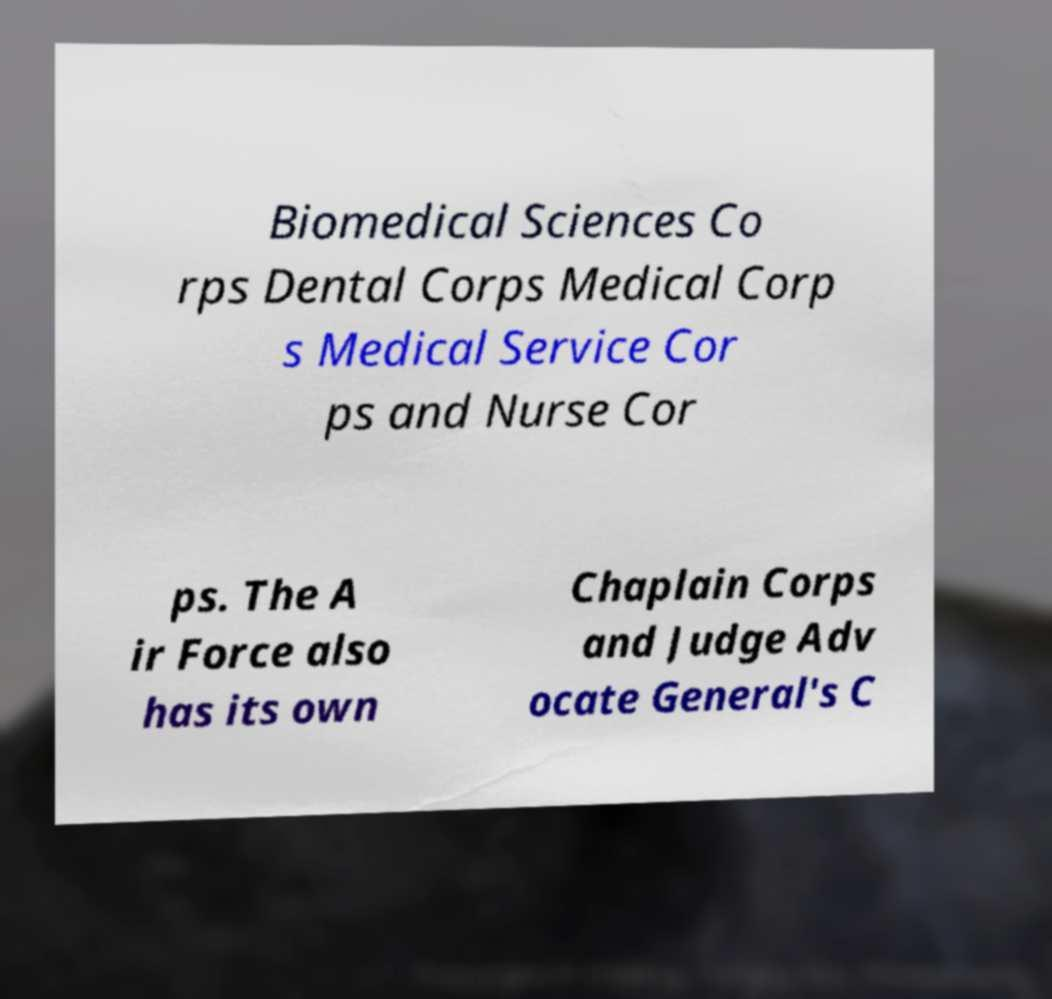Please read and relay the text visible in this image. What does it say? Biomedical Sciences Co rps Dental Corps Medical Corp s Medical Service Cor ps and Nurse Cor ps. The A ir Force also has its own Chaplain Corps and Judge Adv ocate General's C 